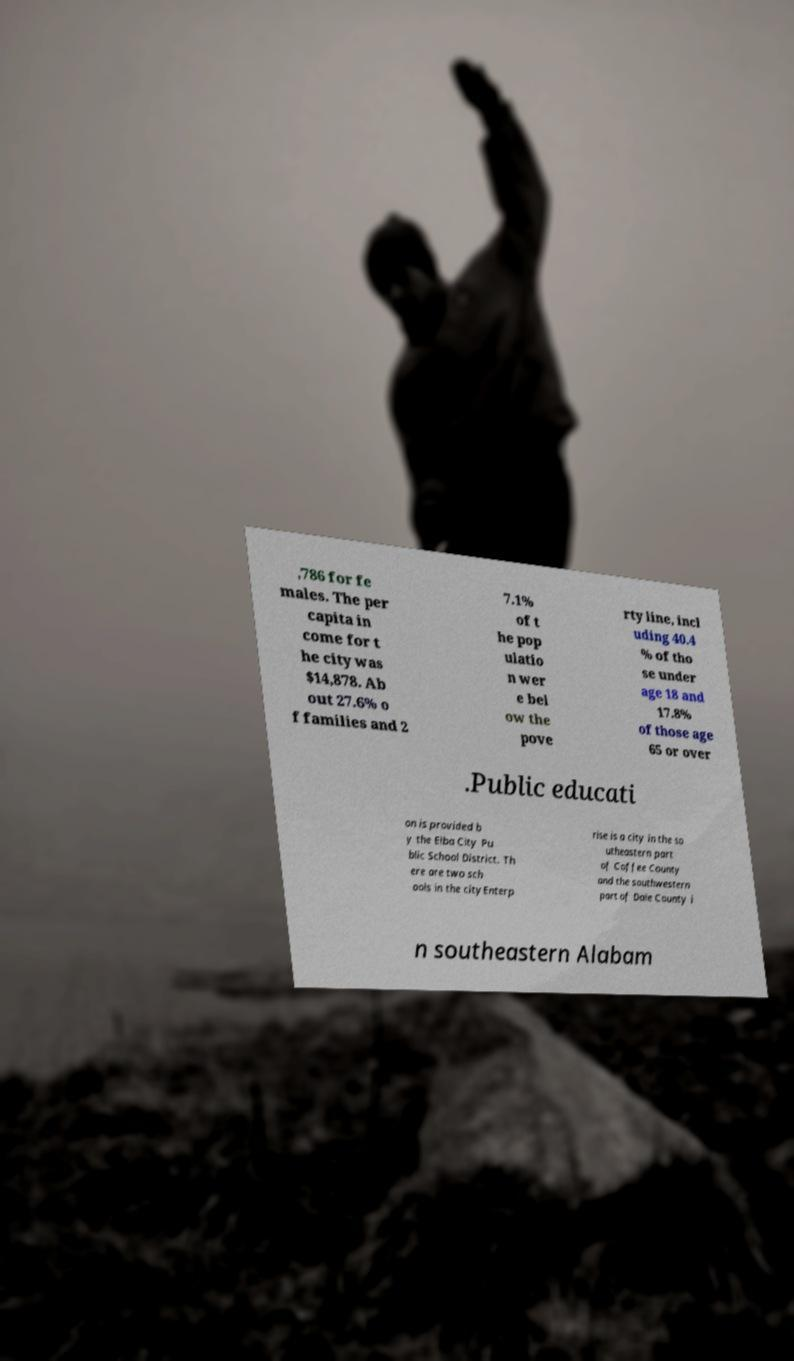Please identify and transcribe the text found in this image. ,786 for fe males. The per capita in come for t he city was $14,878. Ab out 27.6% o f families and 2 7.1% of t he pop ulatio n wer e bel ow the pove rty line, incl uding 40.4 % of tho se under age 18 and 17.8% of those age 65 or over .Public educati on is provided b y the Elba City Pu blic School District. Th ere are two sch ools in the cityEnterp rise is a city in the so utheastern part of Coffee County and the southwestern part of Dale County i n southeastern Alabam 